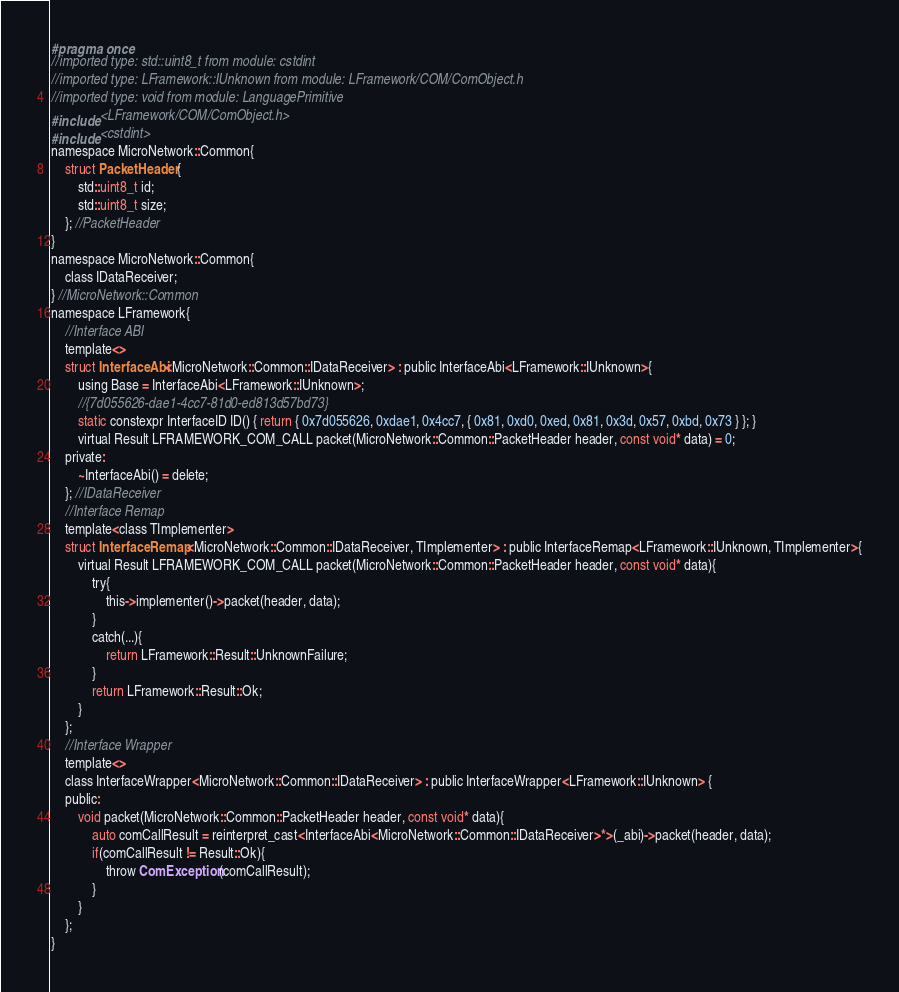Convert code to text. <code><loc_0><loc_0><loc_500><loc_500><_C_>#pragma once
//imported type: std::uint8_t from module: cstdint
//imported type: LFramework::IUnknown from module: LFramework/COM/ComObject.h
//imported type: void from module: LanguagePrimitive
#include <LFramework/COM/ComObject.h>
#include <cstdint>
namespace MicroNetwork::Common{
    struct PacketHeader{
        std::uint8_t id;
        std::uint8_t size;
    }; //PacketHeader
}
namespace MicroNetwork::Common{
    class IDataReceiver;
} //MicroNetwork::Common
namespace LFramework{
    //Interface ABI
    template<>
    struct InterfaceAbi<MicroNetwork::Common::IDataReceiver> : public InterfaceAbi<LFramework::IUnknown>{
        using Base = InterfaceAbi<LFramework::IUnknown>;
        //{7d055626-dae1-4cc7-81d0-ed813d57bd73}
        static constexpr InterfaceID ID() { return { 0x7d055626, 0xdae1, 0x4cc7, { 0x81, 0xd0, 0xed, 0x81, 0x3d, 0x57, 0xbd, 0x73 } }; }
        virtual Result LFRAMEWORK_COM_CALL packet(MicroNetwork::Common::PacketHeader header, const void* data) = 0;
    private:
        ~InterfaceAbi() = delete;
    }; //IDataReceiver
    //Interface Remap
    template<class TImplementer>
    struct InterfaceRemap<MicroNetwork::Common::IDataReceiver, TImplementer> : public InterfaceRemap<LFramework::IUnknown, TImplementer>{
        virtual Result LFRAMEWORK_COM_CALL packet(MicroNetwork::Common::PacketHeader header, const void* data){
            try{
                this->implementer()->packet(header, data);
            }
            catch(...){
                return LFramework::Result::UnknownFailure;
            }
            return LFramework::Result::Ok;
        }
    };
    //Interface Wrapper
    template<>
    class InterfaceWrapper<MicroNetwork::Common::IDataReceiver> : public InterfaceWrapper<LFramework::IUnknown> {
    public:
        void packet(MicroNetwork::Common::PacketHeader header, const void* data){
            auto comCallResult = reinterpret_cast<InterfaceAbi<MicroNetwork::Common::IDataReceiver>*>(_abi)->packet(header, data);
            if(comCallResult != Result::Ok){
                throw ComException(comCallResult);
            }
        }
    };
}

</code> 